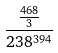Convert formula to latex. <formula><loc_0><loc_0><loc_500><loc_500>\frac { \frac { 4 6 8 } { 3 } } { 2 3 8 ^ { 3 9 4 } }</formula> 